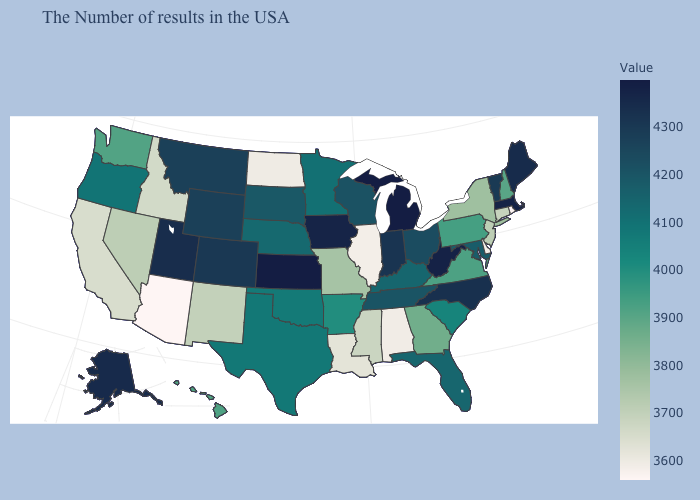Which states hav the highest value in the South?
Short answer required. West Virginia. Which states have the highest value in the USA?
Write a very short answer. Kansas. Which states hav the highest value in the South?
Be succinct. West Virginia. Among the states that border North Dakota , which have the lowest value?
Write a very short answer. Minnesota. Which states have the lowest value in the USA?
Short answer required. Arizona. Is the legend a continuous bar?
Concise answer only. Yes. Which states have the highest value in the USA?
Keep it brief. Kansas. Among the states that border South Dakota , which have the highest value?
Short answer required. Iowa. Does Alaska have the highest value in the West?
Quick response, please. Yes. 